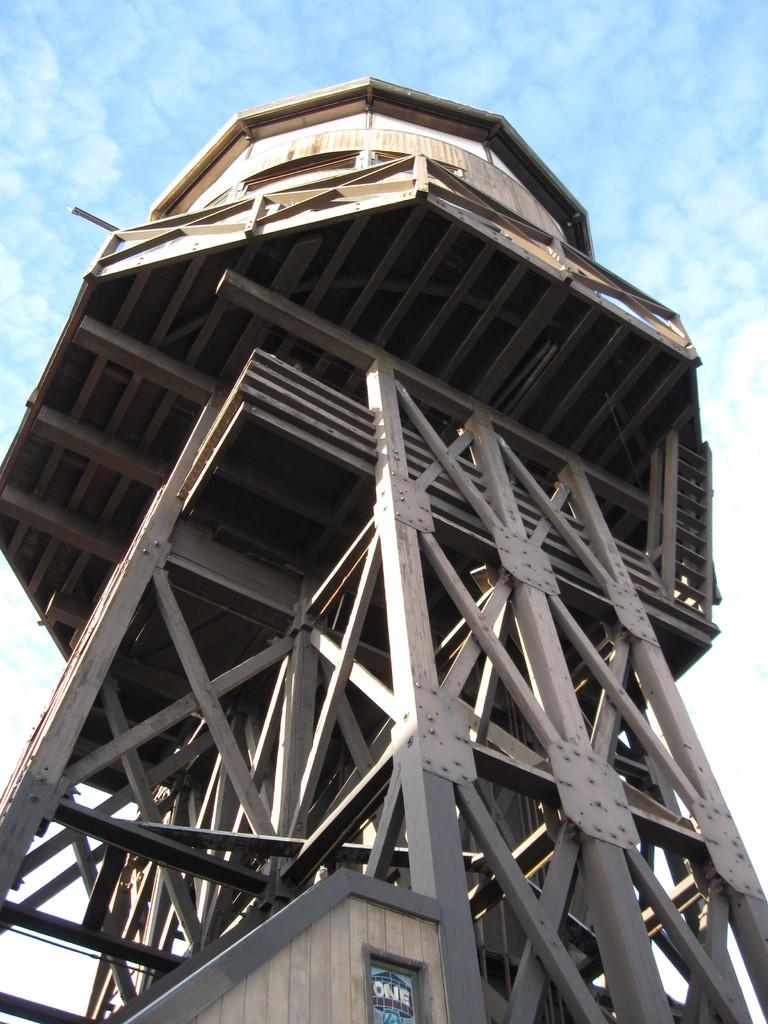What is the main structure in the image? There is a tower in the image. What feature can be seen on the roof of the tower? The tower has metal rods attached to its roof. What can be seen in the background of the image? The sky is visible in the background of the image. What is the condition of the sky in the image? There are clouds in the sky. What type of crack can be seen on the actor's face in the image? There is no actor or crack present in the image; it features a tower with metal rods on its roof and a cloudy sky in the background. 